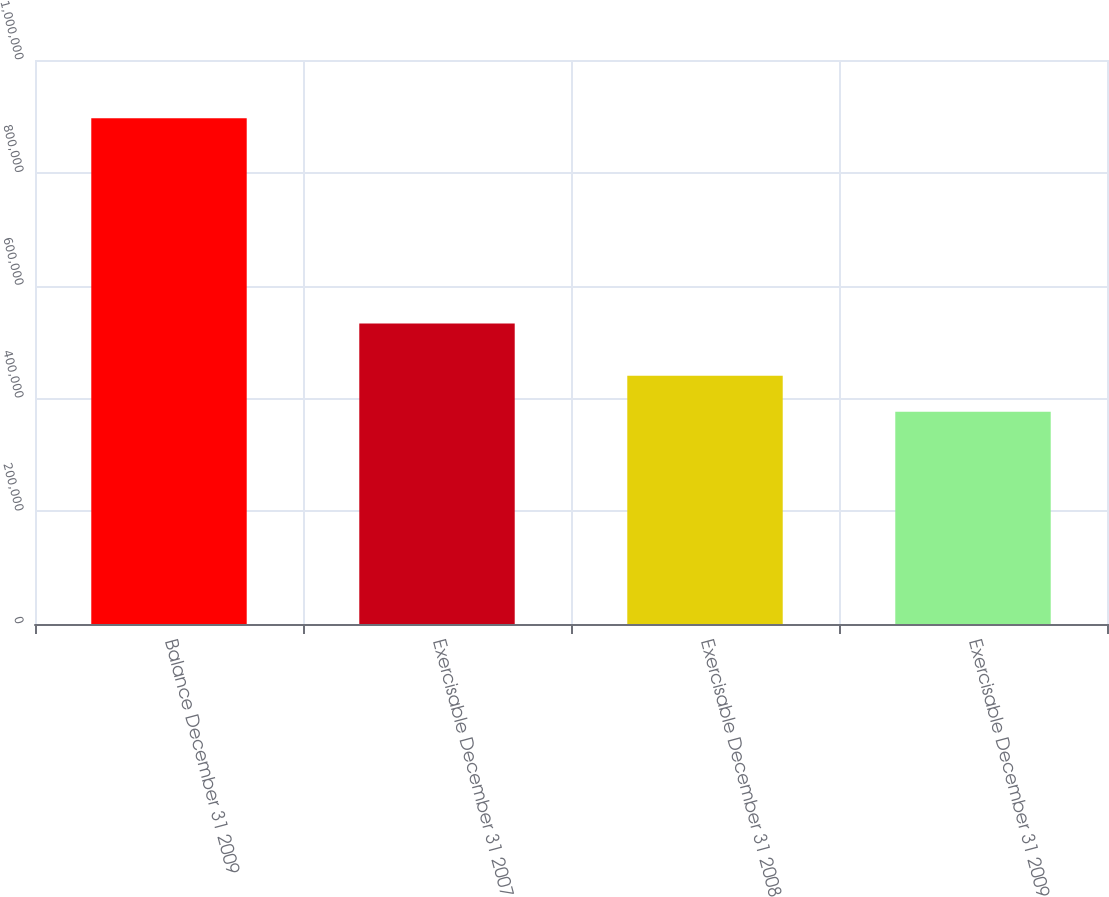<chart> <loc_0><loc_0><loc_500><loc_500><bar_chart><fcel>Balance December 31 2009<fcel>Exercisable December 31 2007<fcel>Exercisable December 31 2008<fcel>Exercisable December 31 2009<nl><fcel>896830<fcel>532750<fcel>440080<fcel>376450<nl></chart> 